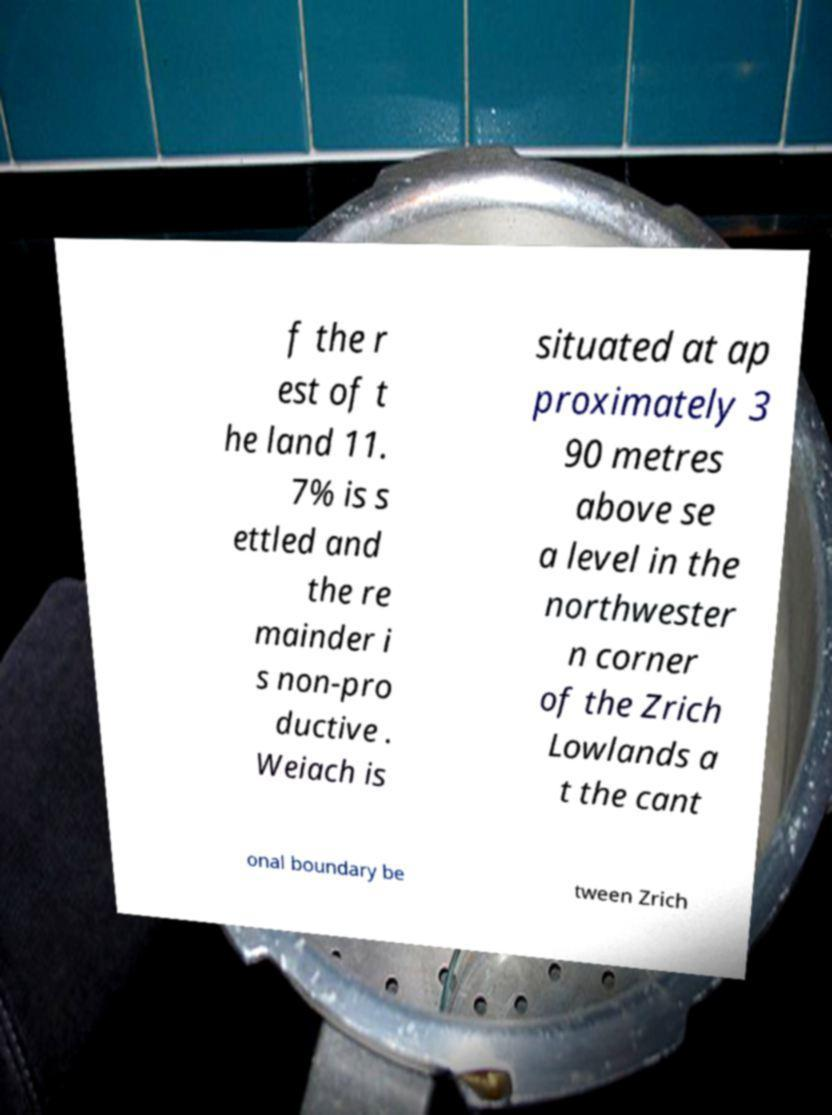Could you extract and type out the text from this image? f the r est of t he land 11. 7% is s ettled and the re mainder i s non-pro ductive . Weiach is situated at ap proximately 3 90 metres above se a level in the northwester n corner of the Zrich Lowlands a t the cant onal boundary be tween Zrich 